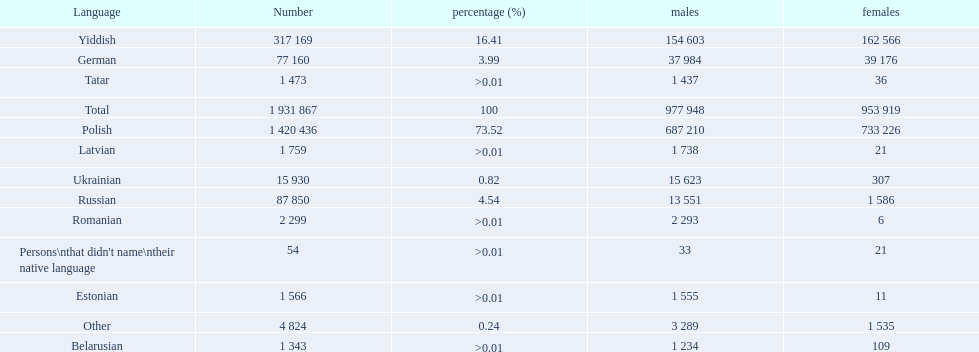How many languages are there? Polish, Yiddish, Russian, German, Ukrainian, Romanian, Latvian, Estonian, Tatar, Belarusian. Which language do more people speak? Polish. 